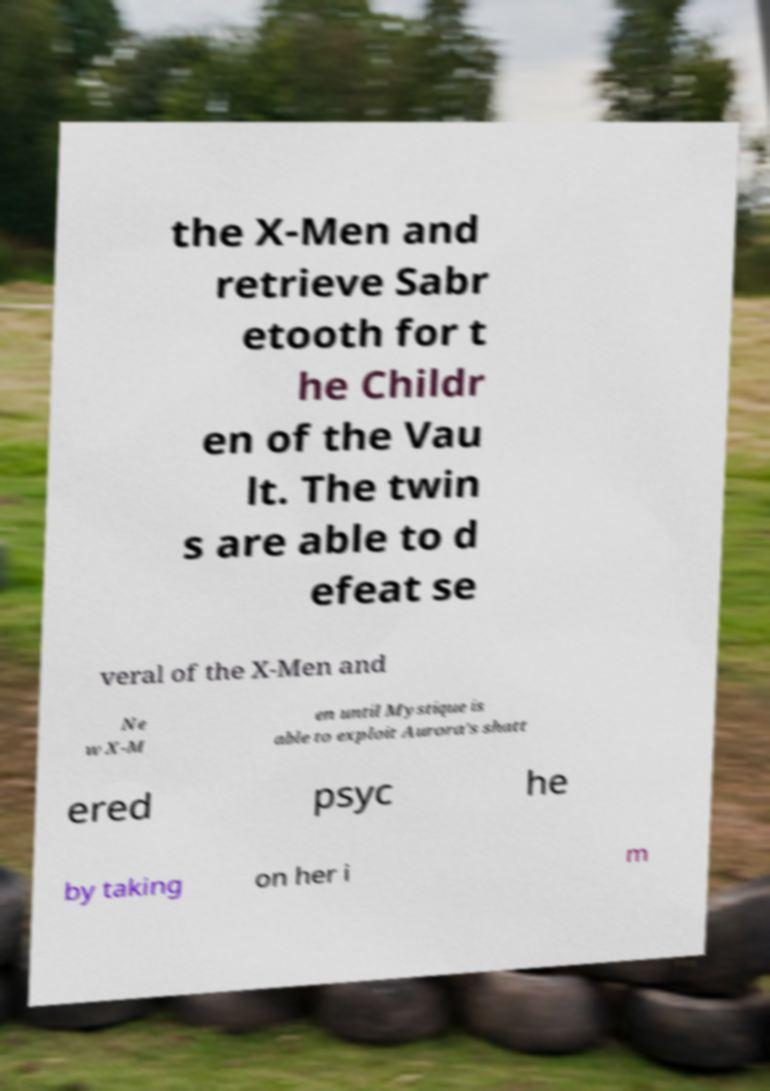Can you read and provide the text displayed in the image?This photo seems to have some interesting text. Can you extract and type it out for me? the X-Men and retrieve Sabr etooth for t he Childr en of the Vau lt. The twin s are able to d efeat se veral of the X-Men and Ne w X-M en until Mystique is able to exploit Aurora's shatt ered psyc he by taking on her i m 